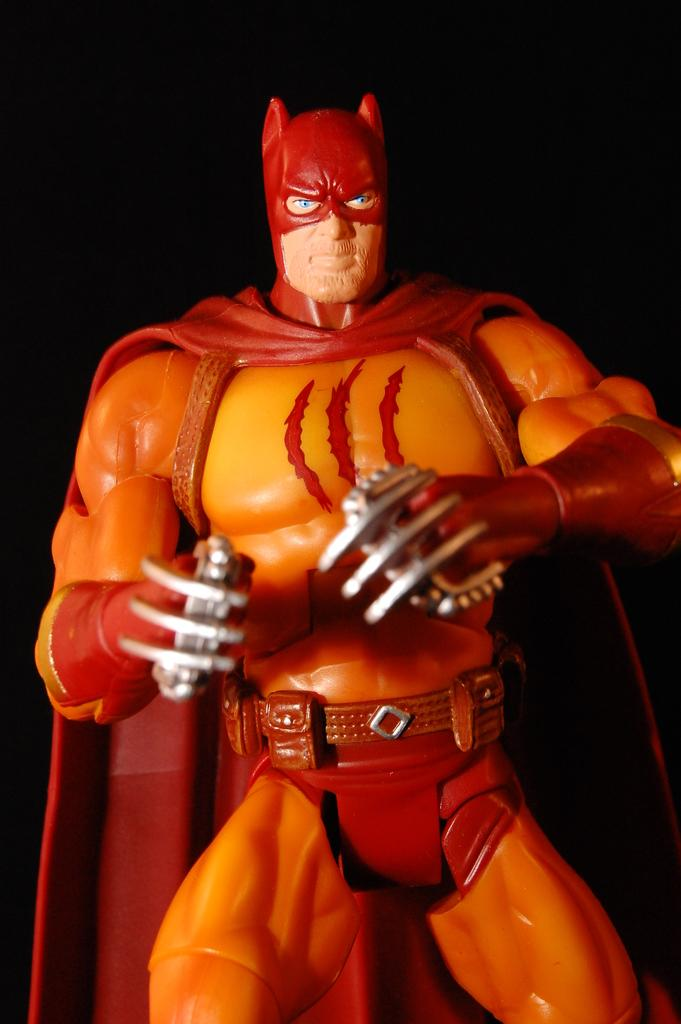What type of toy is in the image? There is a superhero toy in the image. What color is the superhero toy? The superhero toy is orange in color. What can be seen in the background of the image? The background of the image is dark. What type of shoe is visible in the image? There is no shoe present in the image. What cause does the superhero toy represent in the image? The image does not provide information about the cause the superhero toy represents. 